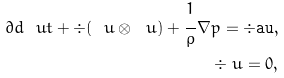Convert formula to latex. <formula><loc_0><loc_0><loc_500><loc_500>\partial d { \ u } { t } + \div ( \ u \otimes \ u ) + \cfrac { 1 } { \rho } \, \nabla p = \div \tt a u , \\ \div \ u = 0 ,</formula> 